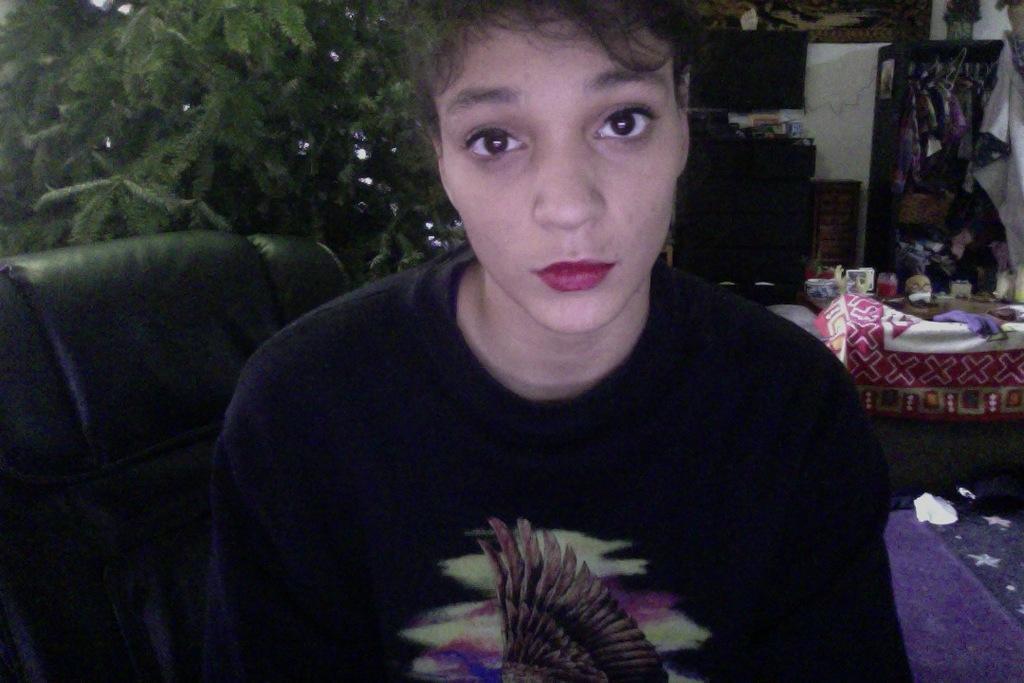How would you summarize this image in a sentence or two? In the image we can see a person, in the middle of the image. The person is wearing clothes, here we can see the sofa, leaves and the bed sheet. Where we can see the clothes hung to the hanger. 